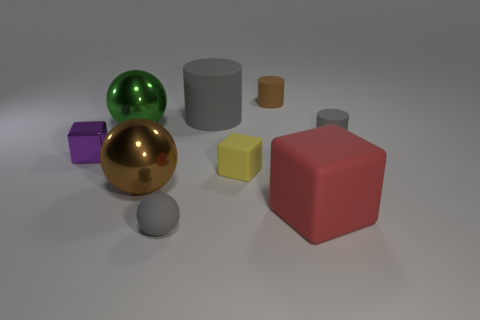What is the color of the small ball that is the same material as the red object?
Provide a succinct answer. Gray. What number of cubes are either large green shiny things or yellow rubber things?
Ensure brevity in your answer.  1. What number of objects are blue rubber cylinders or tiny gray matte things left of the big cylinder?
Provide a short and direct response. 1. Are any tiny metallic cubes visible?
Provide a short and direct response. Yes. What number of balls have the same color as the large block?
Offer a very short reply. 0. There is another cylinder that is the same color as the big cylinder; what is it made of?
Provide a succinct answer. Rubber. What size is the metallic object that is behind the small cube that is left of the large cylinder?
Offer a terse response. Large. Are there any big red objects made of the same material as the large brown ball?
Offer a very short reply. No. There is a green object that is the same size as the red rubber block; what material is it?
Give a very brief answer. Metal. Do the small thing that is to the left of the small gray rubber ball and the matte cylinder that is right of the big matte cube have the same color?
Give a very brief answer. No. 